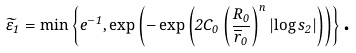Convert formula to latex. <formula><loc_0><loc_0><loc_500><loc_500>\widetilde { \varepsilon } _ { 1 } = \min \left \{ e ^ { - 1 } , \exp \left ( - \exp \left ( 2 C _ { 0 } \left ( \frac { R _ { 0 } } { \overline { r } _ { 0 } } \right ) ^ { n } \left | \log s _ { 2 } \right | \right ) \right ) \right \} \text {.}</formula> 